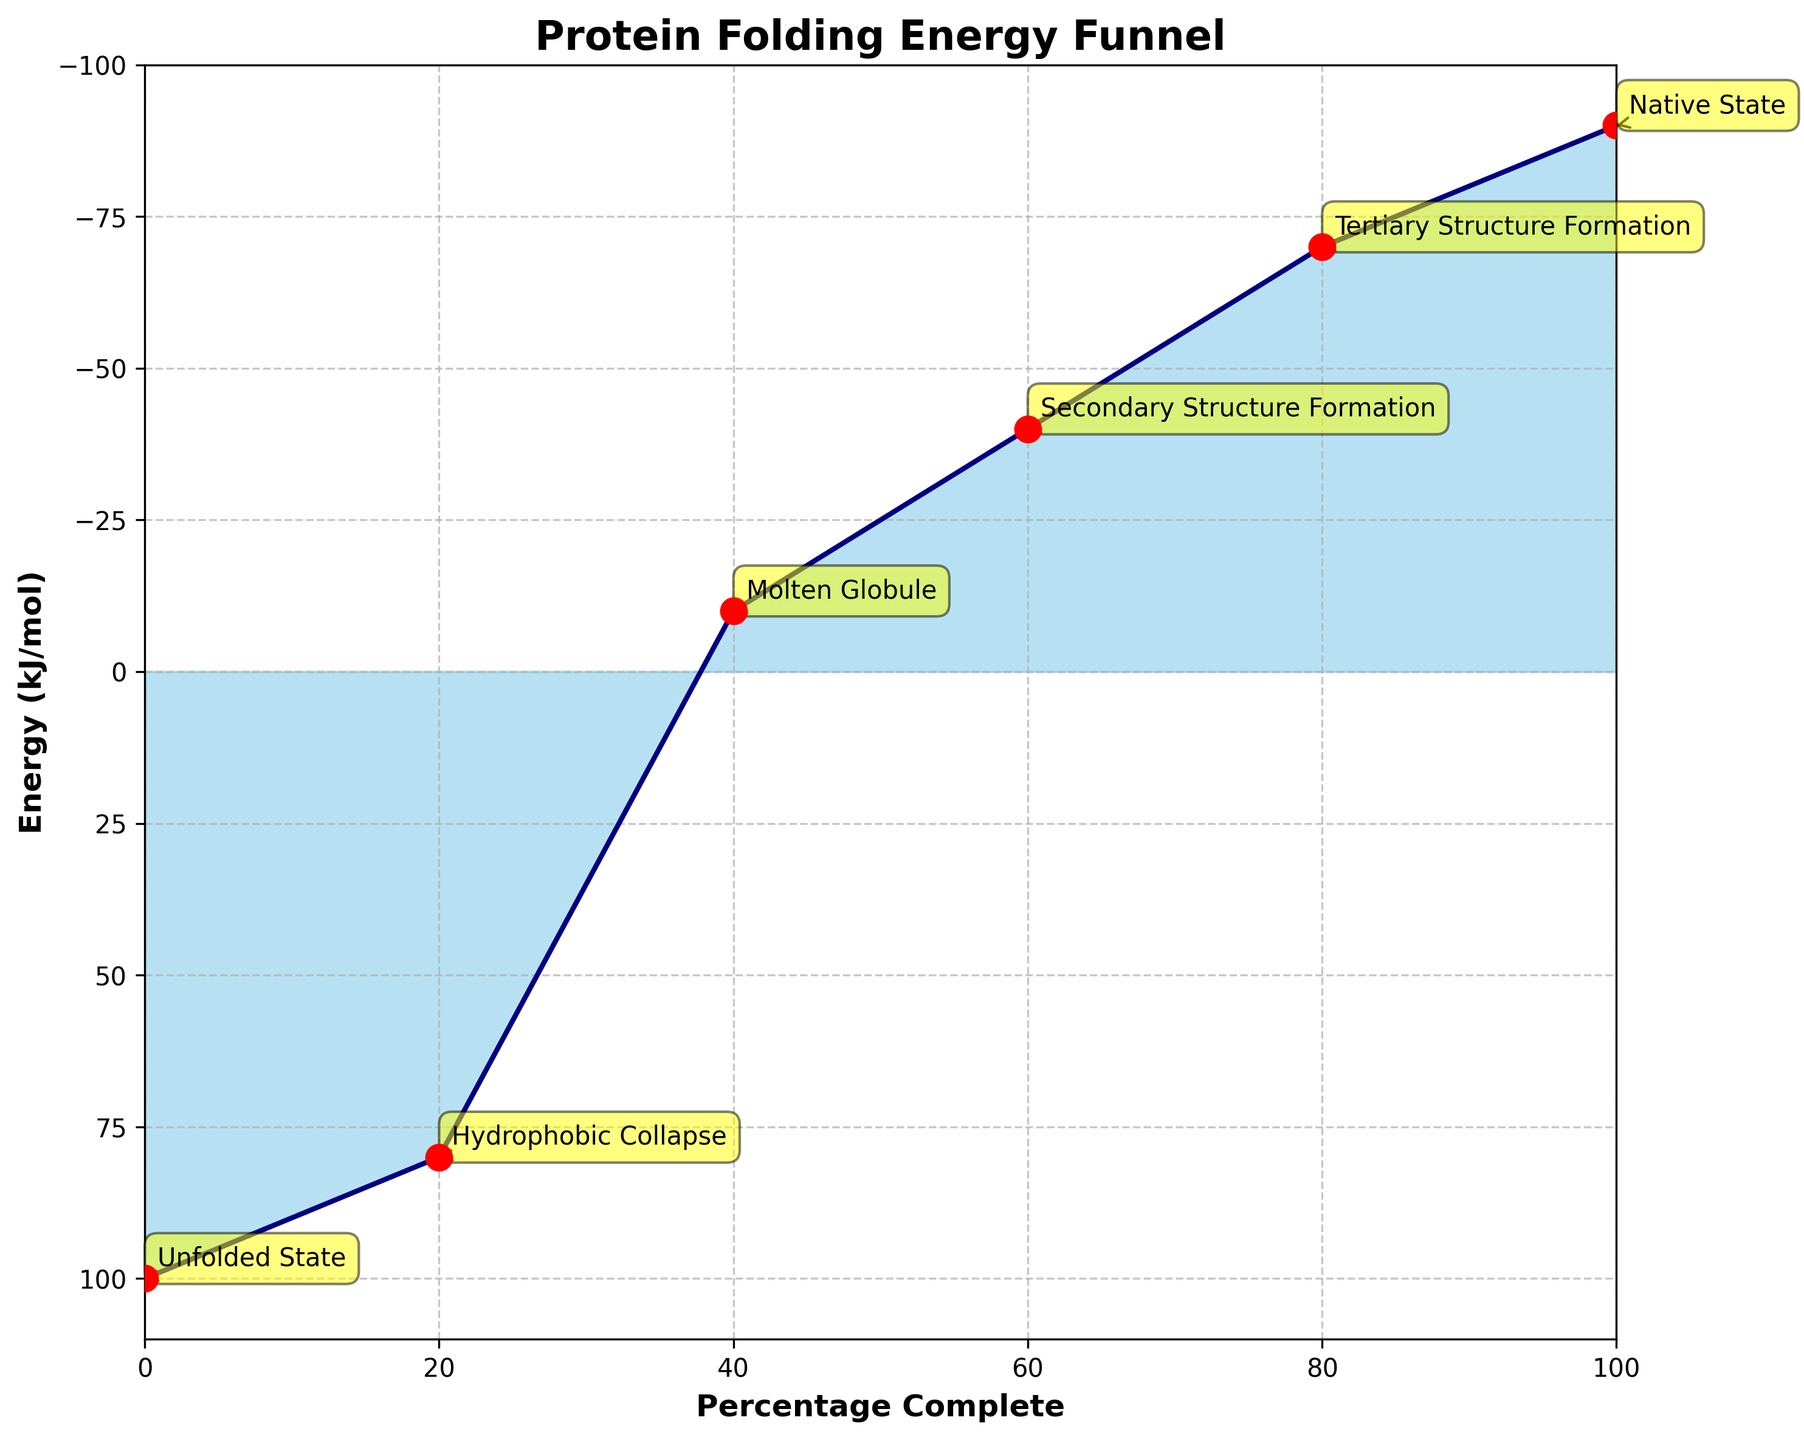What's the title of the figure? The title of the figure is prominently displayed at the top center.
Answer: Protein Folding Energy Funnel What's the energy level (in kJ/mol) at the Unfolded State stage? The energy level of each stage is marked along the y-axis, with specific energy values noted next to the annotated markers. The Unfolded State is at the topmost stage.
Answer: 100 How many stages of protein folding are shown in the figure? Stages are explicitly labeled and annotated along the curve. Each annotation represents a different stage. Count these annotations to find the number of stages.
Answer: 6 During which stage is the protein folding process 60% complete? The x-axis represents the percentage complete. Locate 60% on the x-axis and identify the stage marker corresponding to it.
Answer: Secondary Structure Formation What is the difference in energy level between the Hydrophobic Collapse and the Native State stages? The energy levels for Hydrophobic Collapse and Native State can be read from the y-axis. Subtract the energy level of the Native State from that of the Hydrophobic Collapse: 80 - (-90).
Answer: 170 kJ/mol Which stage has the largest decrease in energy from the previous stage? Compare the energy differences between consecutive stages. The largest difference indicates the most significant decrease. Between Unfolded State and Hydrophobic Collapse, the decrease is 100 - 80 = 20. Between Hydrophobic Collapse and Molten Globule, it is 80 - (-10) = 90. Continue this for all stages.
Answer: Hydrophobic Collapse to Molten Globule Which stage represents the lowest energy level? The y-axis marks energy levels, and the stage annotations indicate specific stages. Find the lowest point on the y-axis corresponding to a stage marker.
Answer: Native State If the protein is at the Secondary Structure Formation stage, what percentage of the folding process remains? The Secondary Structure Formation stage is at 60% complete. Subtract this from 100% to find the remaining percentage: 100 - 60.
Answer: 40% What is the average energy level (in kJ/mol) for the distinctive stages of protein folding? Sum the energy levels of all stages and divide by the number of stages. (100 + 80 + (-10) + (-40) + (-70) + (-90)) / 6.
Answer: -5 kJ/mol 